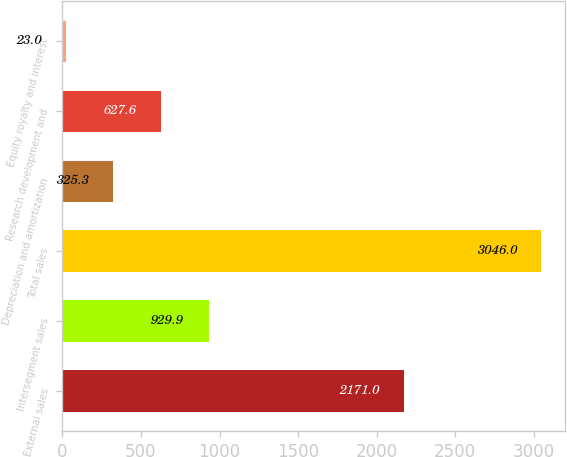Convert chart to OTSL. <chart><loc_0><loc_0><loc_500><loc_500><bar_chart><fcel>External sales<fcel>Intersegment sales<fcel>Total sales<fcel>Depreciation and amortization<fcel>Research development and<fcel>Equity royalty and interest<nl><fcel>2171<fcel>929.9<fcel>3046<fcel>325.3<fcel>627.6<fcel>23<nl></chart> 